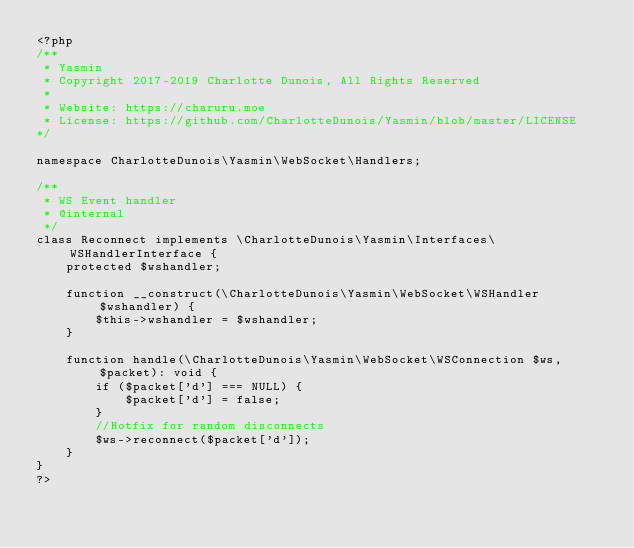<code> <loc_0><loc_0><loc_500><loc_500><_PHP_><?php
/**
 * Yasmin
 * Copyright 2017-2019 Charlotte Dunois, All Rights Reserved
 *
 * Website: https://charuru.moe
 * License: https://github.com/CharlotteDunois/Yasmin/blob/master/LICENSE
*/

namespace CharlotteDunois\Yasmin\WebSocket\Handlers;

/**
 * WS Event handler
 * @internal
 */
class Reconnect implements \CharlotteDunois\Yasmin\Interfaces\WSHandlerInterface {
    protected $wshandler;
    
    function __construct(\CharlotteDunois\Yasmin\WebSocket\WSHandler $wshandler) {
        $this->wshandler = $wshandler;
    }
    
    function handle(\CharlotteDunois\Yasmin\WebSocket\WSConnection $ws, $packet): void {
        if ($packet['d'] === NULL) {
            $packet['d'] = false;
        }
        //Hotfix for random disconnects
        $ws->reconnect($packet['d']);
    }
}
?>
</code> 